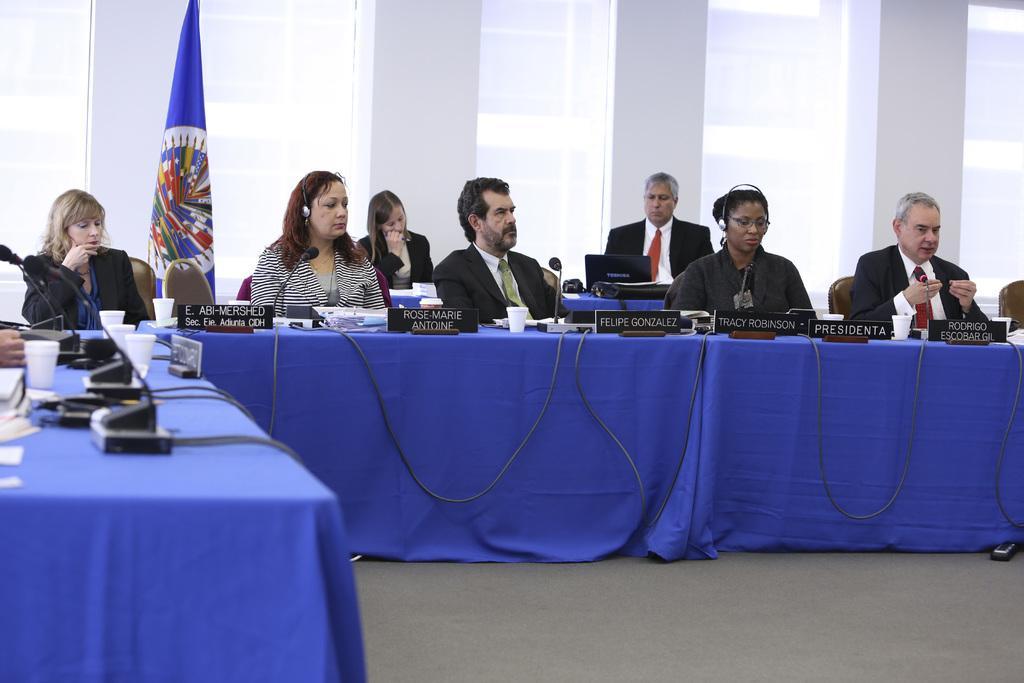Please provide a concise description of this image. In the image we can see there are people who are sitting on chair and on table there are glasses, name plates, mic with a stand and at the back people are standing and there is a blue colour flag. 